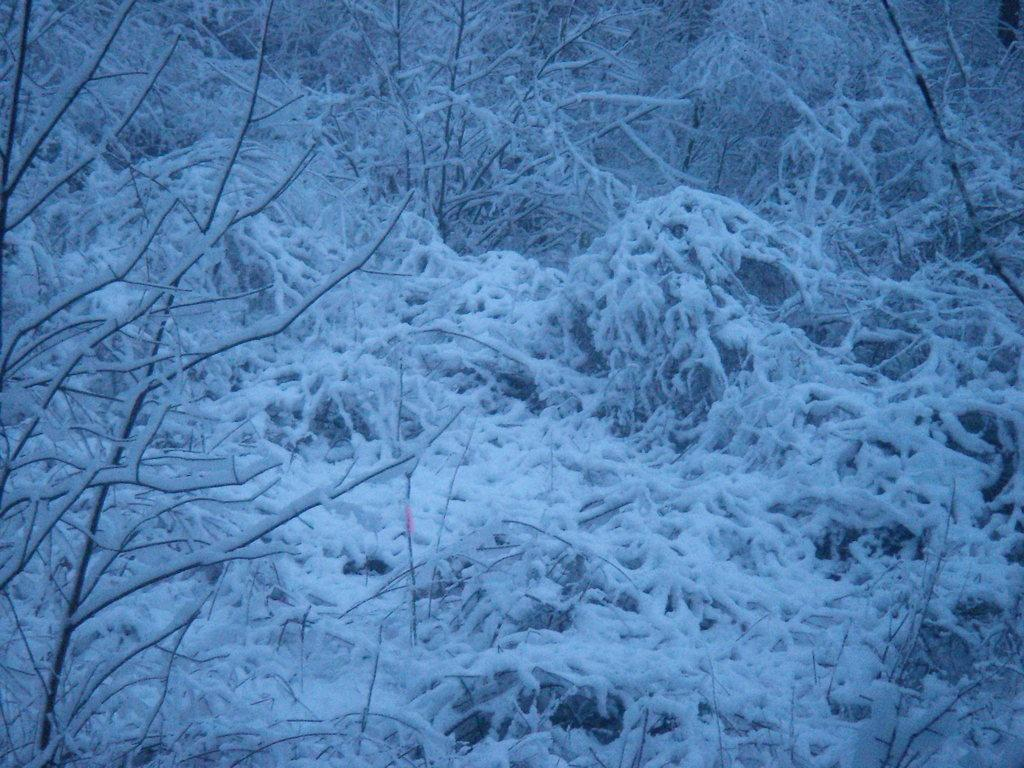What type of vegetation can be seen in the image? There are trees in the image. How are the trees in the image affected by the weather? The trees are covered by snow in the image. What type of beast can be heard making sounds in the image? There is no beast or sound present in the image; it only features trees covered in snow. Can you describe the earthquake happening in the image? There is no earthquake depicted in the image; it only shows trees covered in snow. 